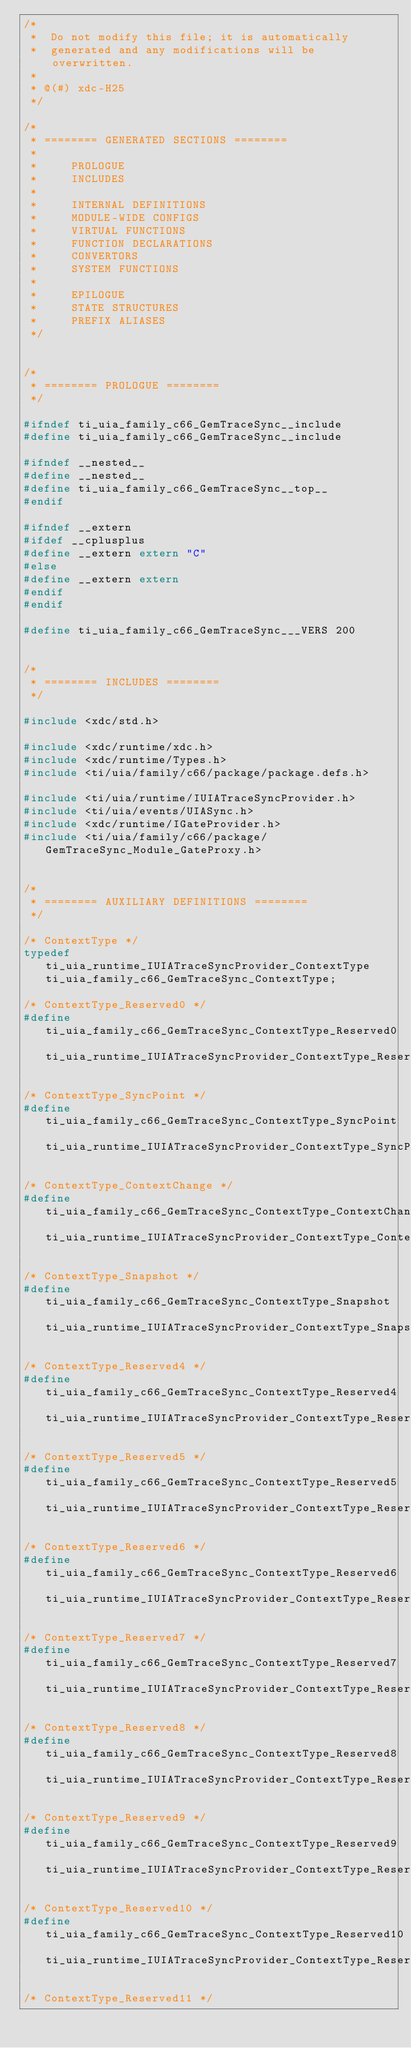Convert code to text. <code><loc_0><loc_0><loc_500><loc_500><_C_>/*
 *  Do not modify this file; it is automatically 
 *  generated and any modifications will be overwritten.
 *
 * @(#) xdc-H25
 */

/*
 * ======== GENERATED SECTIONS ========
 *
 *     PROLOGUE
 *     INCLUDES
 *
 *     INTERNAL DEFINITIONS
 *     MODULE-WIDE CONFIGS
 *     VIRTUAL FUNCTIONS
 *     FUNCTION DECLARATIONS
 *     CONVERTORS
 *     SYSTEM FUNCTIONS
 *
 *     EPILOGUE
 *     STATE STRUCTURES
 *     PREFIX ALIASES
 */


/*
 * ======== PROLOGUE ========
 */

#ifndef ti_uia_family_c66_GemTraceSync__include
#define ti_uia_family_c66_GemTraceSync__include

#ifndef __nested__
#define __nested__
#define ti_uia_family_c66_GemTraceSync__top__
#endif

#ifndef __extern
#ifdef __cplusplus
#define __extern extern "C"
#else
#define __extern extern
#endif
#endif

#define ti_uia_family_c66_GemTraceSync___VERS 200


/*
 * ======== INCLUDES ========
 */

#include <xdc/std.h>

#include <xdc/runtime/xdc.h>
#include <xdc/runtime/Types.h>
#include <ti/uia/family/c66/package/package.defs.h>

#include <ti/uia/runtime/IUIATraceSyncProvider.h>
#include <ti/uia/events/UIASync.h>
#include <xdc/runtime/IGateProvider.h>
#include <ti/uia/family/c66/package/GemTraceSync_Module_GateProxy.h>


/*
 * ======== AUXILIARY DEFINITIONS ========
 */

/* ContextType */
typedef ti_uia_runtime_IUIATraceSyncProvider_ContextType ti_uia_family_c66_GemTraceSync_ContextType;

/* ContextType_Reserved0 */
#define ti_uia_family_c66_GemTraceSync_ContextType_Reserved0 ti_uia_runtime_IUIATraceSyncProvider_ContextType_Reserved0

/* ContextType_SyncPoint */
#define ti_uia_family_c66_GemTraceSync_ContextType_SyncPoint ti_uia_runtime_IUIATraceSyncProvider_ContextType_SyncPoint

/* ContextType_ContextChange */
#define ti_uia_family_c66_GemTraceSync_ContextType_ContextChange ti_uia_runtime_IUIATraceSyncProvider_ContextType_ContextChange

/* ContextType_Snapshot */
#define ti_uia_family_c66_GemTraceSync_ContextType_Snapshot ti_uia_runtime_IUIATraceSyncProvider_ContextType_Snapshot

/* ContextType_Reserved4 */
#define ti_uia_family_c66_GemTraceSync_ContextType_Reserved4 ti_uia_runtime_IUIATraceSyncProvider_ContextType_Reserved4

/* ContextType_Reserved5 */
#define ti_uia_family_c66_GemTraceSync_ContextType_Reserved5 ti_uia_runtime_IUIATraceSyncProvider_ContextType_Reserved5

/* ContextType_Reserved6 */
#define ti_uia_family_c66_GemTraceSync_ContextType_Reserved6 ti_uia_runtime_IUIATraceSyncProvider_ContextType_Reserved6

/* ContextType_Reserved7 */
#define ti_uia_family_c66_GemTraceSync_ContextType_Reserved7 ti_uia_runtime_IUIATraceSyncProvider_ContextType_Reserved7

/* ContextType_Reserved8 */
#define ti_uia_family_c66_GemTraceSync_ContextType_Reserved8 ti_uia_runtime_IUIATraceSyncProvider_ContextType_Reserved8

/* ContextType_Reserved9 */
#define ti_uia_family_c66_GemTraceSync_ContextType_Reserved9 ti_uia_runtime_IUIATraceSyncProvider_ContextType_Reserved9

/* ContextType_Reserved10 */
#define ti_uia_family_c66_GemTraceSync_ContextType_Reserved10 ti_uia_runtime_IUIATraceSyncProvider_ContextType_Reserved10

/* ContextType_Reserved11 */</code> 